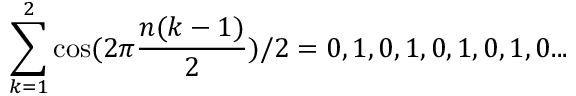<formula> <loc_0><loc_0><loc_500><loc_500>\sum _ { k = 1 } ^ { 2 } \cos ( 2 \pi { \frac { n ( k - 1 ) } { 2 } } ) / 2 = 0 , 1 , 0 , 1 , 0 , 1 , 0 , 1 , 0 \dots</formula> 